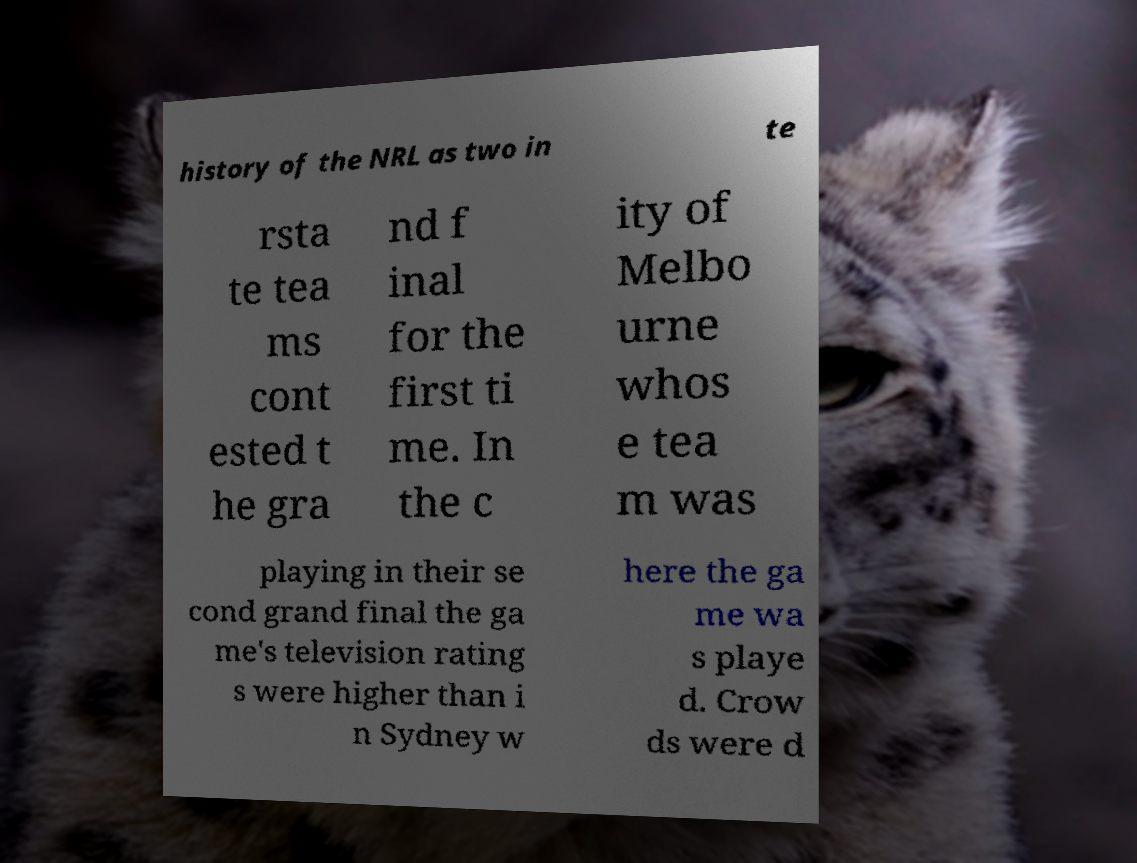Please read and relay the text visible in this image. What does it say? history of the NRL as two in te rsta te tea ms cont ested t he gra nd f inal for the first ti me. In the c ity of Melbo urne whos e tea m was playing in their se cond grand final the ga me's television rating s were higher than i n Sydney w here the ga me wa s playe d. Crow ds were d 